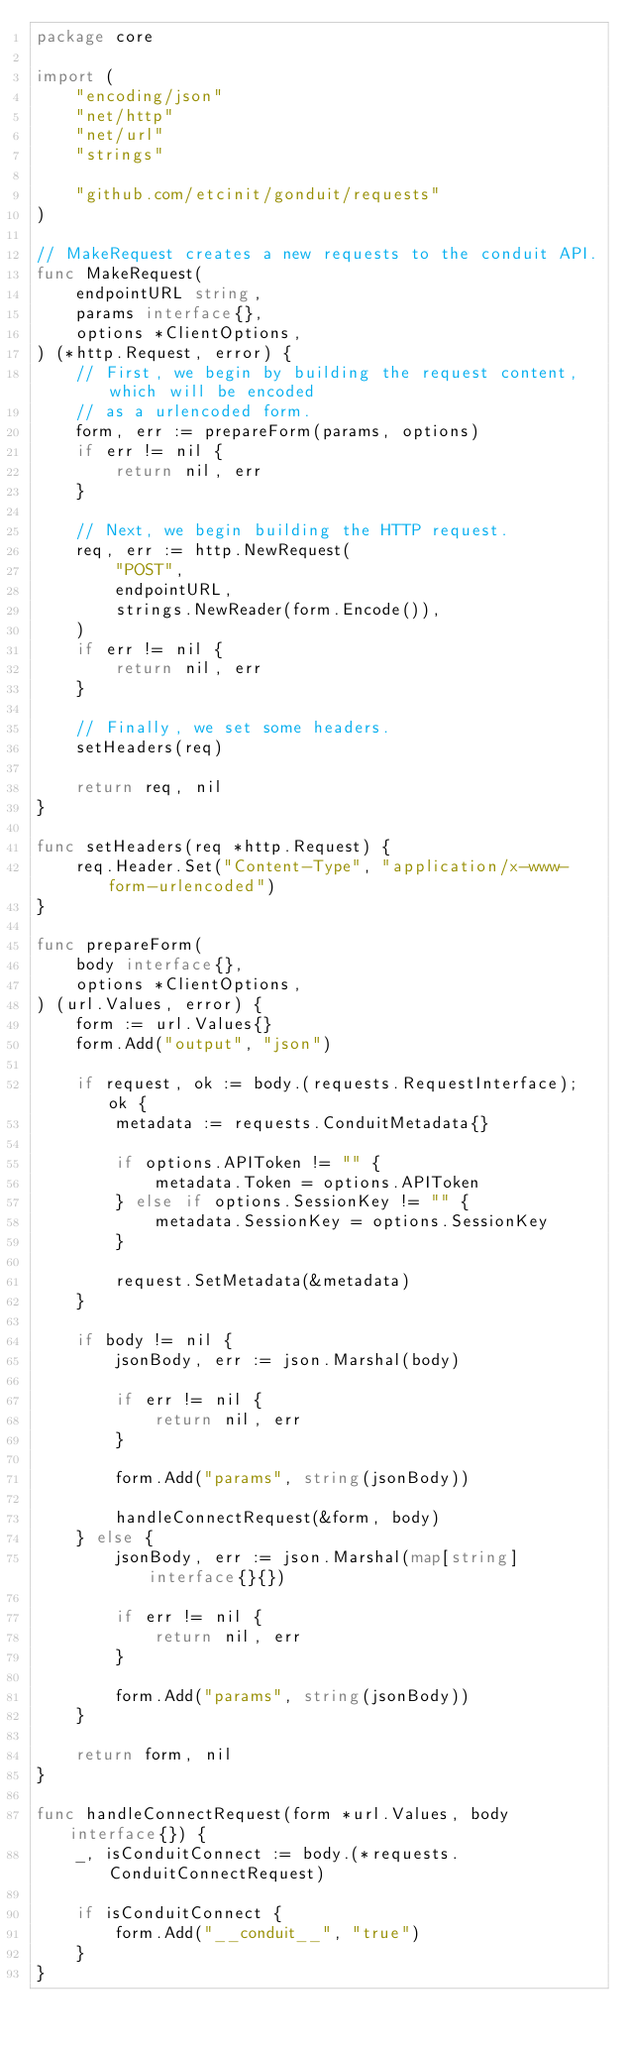<code> <loc_0><loc_0><loc_500><loc_500><_Go_>package core

import (
	"encoding/json"
	"net/http"
	"net/url"
	"strings"

	"github.com/etcinit/gonduit/requests"
)

// MakeRequest creates a new requests to the conduit API.
func MakeRequest(
	endpointURL string,
	params interface{},
	options *ClientOptions,
) (*http.Request, error) {
	// First, we begin by building the request content, which will be encoded
	// as a urlencoded form.
	form, err := prepareForm(params, options)
	if err != nil {
		return nil, err
	}

	// Next, we begin building the HTTP request.
	req, err := http.NewRequest(
		"POST",
		endpointURL,
		strings.NewReader(form.Encode()),
	)
	if err != nil {
		return nil, err
	}

	// Finally, we set some headers.
	setHeaders(req)

	return req, nil
}

func setHeaders(req *http.Request) {
	req.Header.Set("Content-Type", "application/x-www-form-urlencoded")
}

func prepareForm(
	body interface{},
	options *ClientOptions,
) (url.Values, error) {
	form := url.Values{}
	form.Add("output", "json")

	if request, ok := body.(requests.RequestInterface); ok {
		metadata := requests.ConduitMetadata{}

		if options.APIToken != "" {
			metadata.Token = options.APIToken
		} else if options.SessionKey != "" {
			metadata.SessionKey = options.SessionKey
		}

		request.SetMetadata(&metadata)
	}

	if body != nil {
		jsonBody, err := json.Marshal(body)

		if err != nil {
			return nil, err
		}

		form.Add("params", string(jsonBody))

		handleConnectRequest(&form, body)
	} else {
		jsonBody, err := json.Marshal(map[string]interface{}{})

		if err != nil {
			return nil, err
		}

		form.Add("params", string(jsonBody))
	}

	return form, nil
}

func handleConnectRequest(form *url.Values, body interface{}) {
	_, isConduitConnect := body.(*requests.ConduitConnectRequest)

	if isConduitConnect {
		form.Add("__conduit__", "true")
	}
}
</code> 